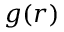Convert formula to latex. <formula><loc_0><loc_0><loc_500><loc_500>g ( r )</formula> 